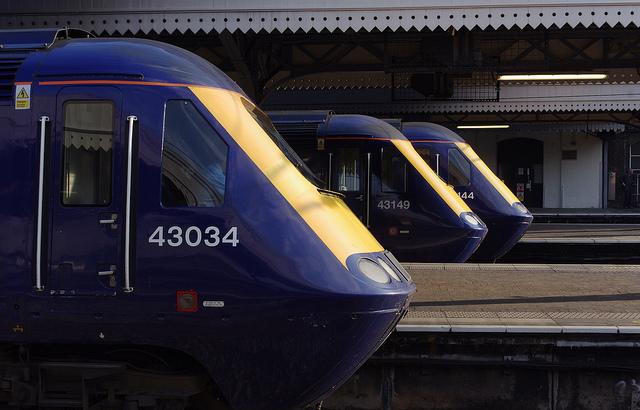What surface allows the trains to be mobile?

Choices:
A) rails
B) cement
C) asphalt
D) pavement rails 